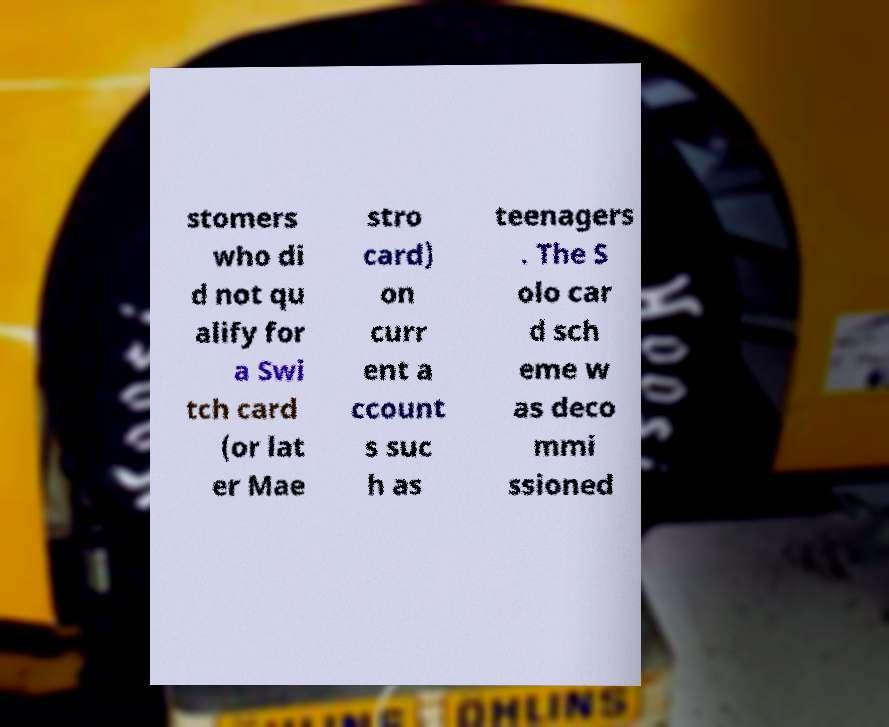There's text embedded in this image that I need extracted. Can you transcribe it verbatim? stomers who di d not qu alify for a Swi tch card (or lat er Mae stro card) on curr ent a ccount s suc h as teenagers . The S olo car d sch eme w as deco mmi ssioned 